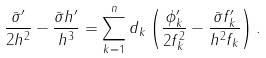<formula> <loc_0><loc_0><loc_500><loc_500>\frac { \bar { \sigma } ^ { \prime } } { 2 h ^ { 2 } } - \frac { \bar { \sigma } h ^ { \prime } } { h ^ { 3 } } = \sum _ { k = 1 } ^ { n } d _ { k } \left ( \frac { \phi _ { k } ^ { \prime } } { 2 f _ { k } ^ { 2 } } - \frac { \bar { \sigma } f _ { k } ^ { \prime } } { h ^ { 2 } f _ { k } } \right ) .</formula> 